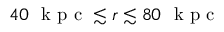<formula> <loc_0><loc_0><loc_500><loc_500>4 0 k p c \lesssim r \lesssim 8 0 k p c</formula> 